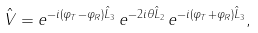<formula> <loc_0><loc_0><loc_500><loc_500>\hat { V } = e ^ { - i ( \varphi _ { T } - \varphi _ { R } ) \hat { L } _ { 3 } } \, e ^ { - 2 i \theta \hat { L } _ { 2 } } \, e ^ { - i ( \varphi _ { T } + \varphi _ { R } ) \hat { L } _ { 3 } } ,</formula> 